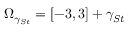Convert formula to latex. <formula><loc_0><loc_0><loc_500><loc_500>\mathcal { \Omega } _ { \gamma _ { S t } } = [ - 3 , 3 ] + \gamma _ { S t }</formula> 